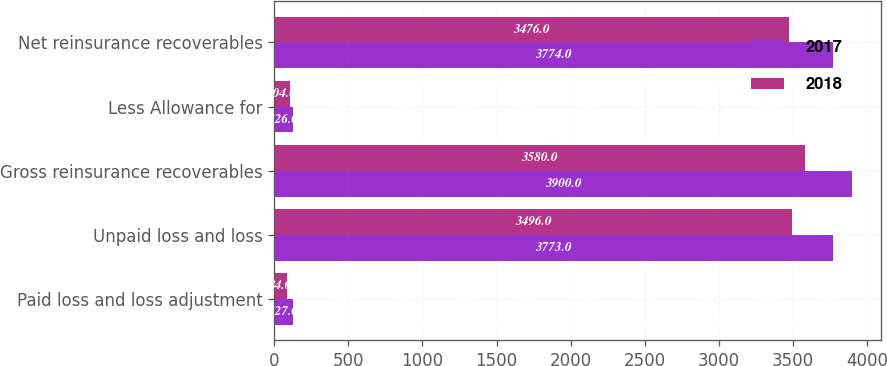<chart> <loc_0><loc_0><loc_500><loc_500><stacked_bar_chart><ecel><fcel>Paid loss and loss adjustment<fcel>Unpaid loss and loss<fcel>Gross reinsurance recoverables<fcel>Less Allowance for<fcel>Net reinsurance recoverables<nl><fcel>2017<fcel>127<fcel>3773<fcel>3900<fcel>126<fcel>3774<nl><fcel>2018<fcel>84<fcel>3496<fcel>3580<fcel>104<fcel>3476<nl></chart> 